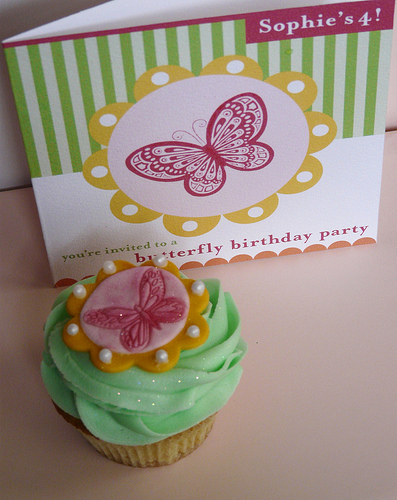<image>
Is the card on the cupcake? No. The card is not positioned on the cupcake. They may be near each other, but the card is not supported by or resting on top of the cupcake. Is the sophie above the butterfly? Yes. The sophie is positioned above the butterfly in the vertical space, higher up in the scene. 